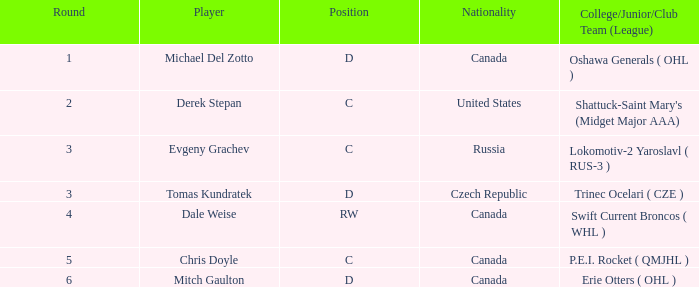What is Michael Del Zotto's nationality? Canada. 